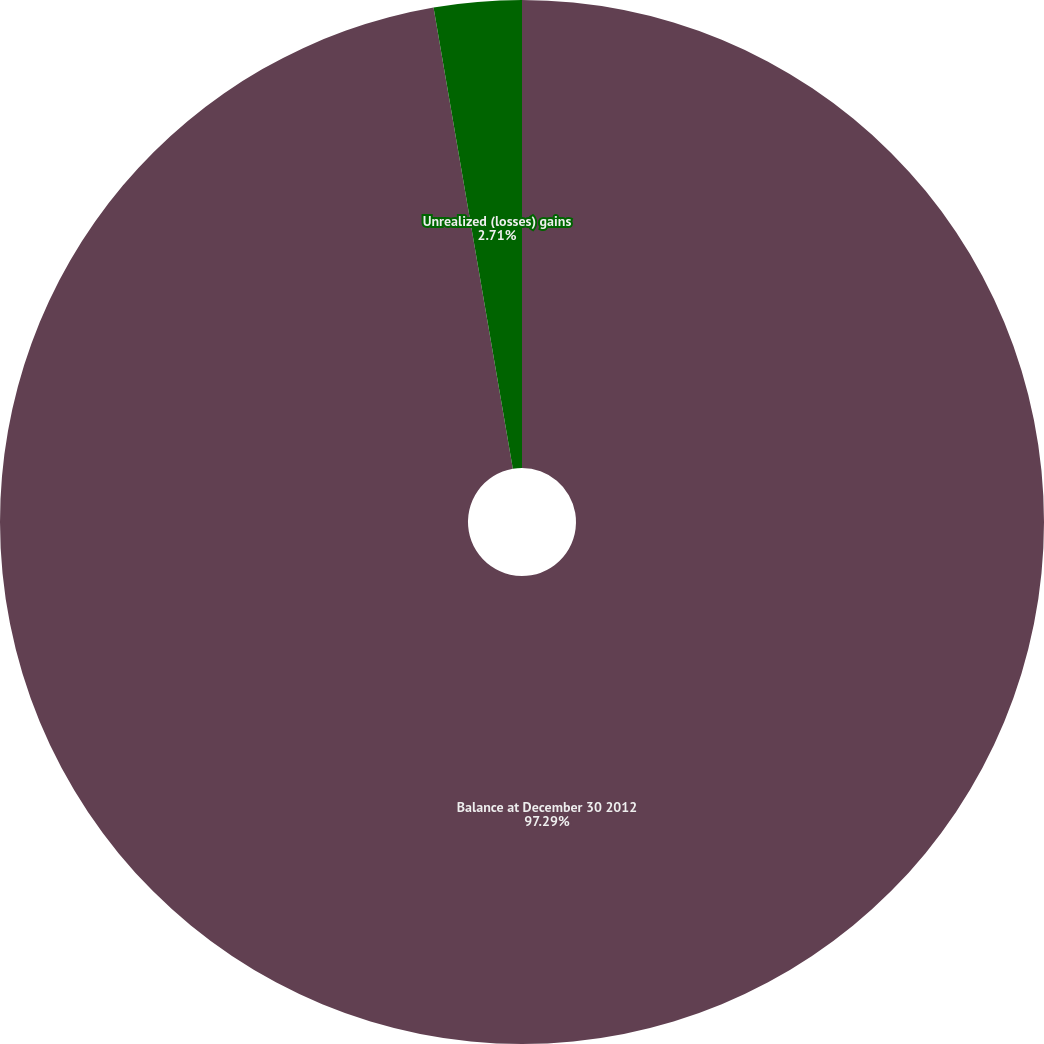Convert chart to OTSL. <chart><loc_0><loc_0><loc_500><loc_500><pie_chart><fcel>Balance at December 30 2012<fcel>Unrealized (losses) gains<nl><fcel>97.29%<fcel>2.71%<nl></chart> 